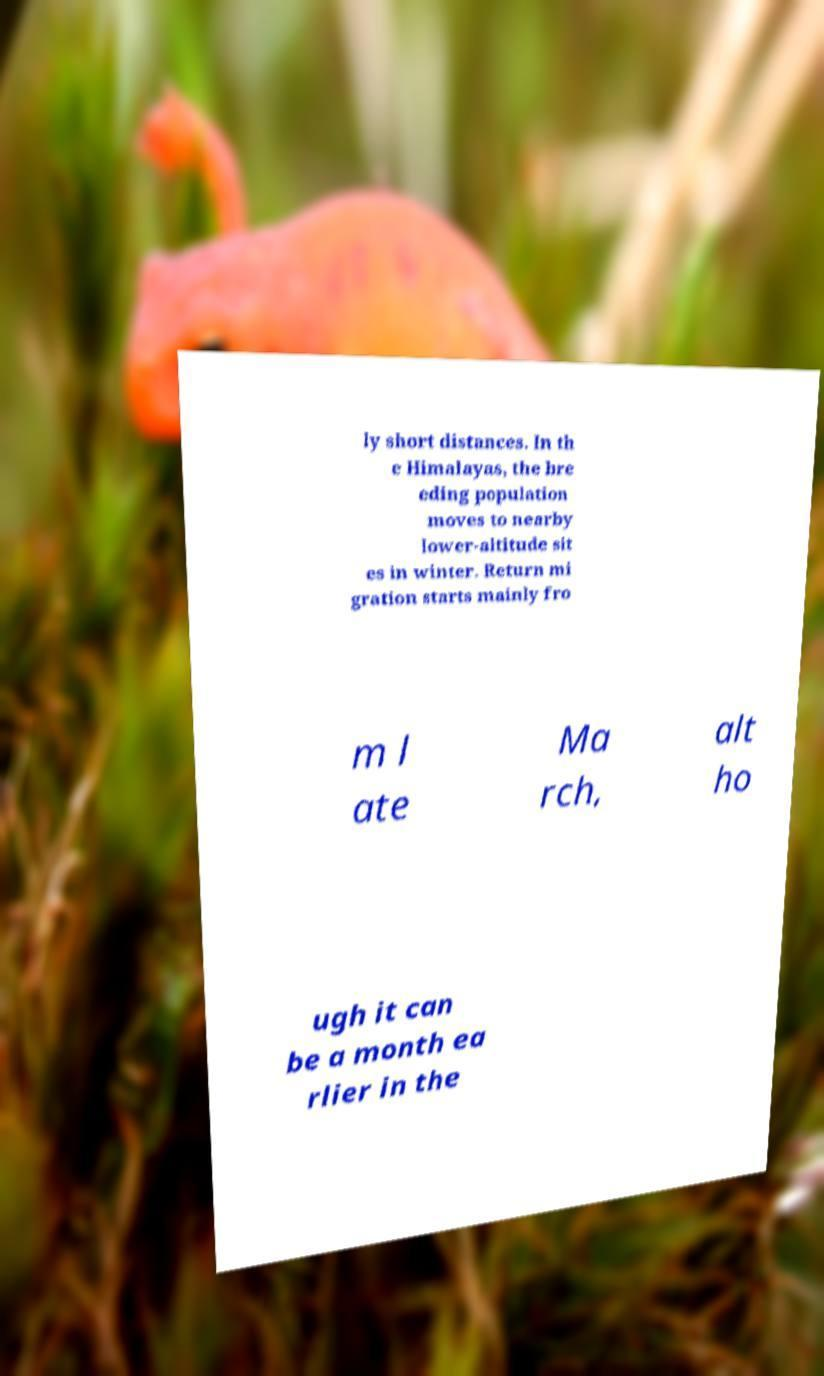Please identify and transcribe the text found in this image. ly short distances. In th e Himalayas, the bre eding population moves to nearby lower-altitude sit es in winter. Return mi gration starts mainly fro m l ate Ma rch, alt ho ugh it can be a month ea rlier in the 